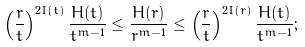<formula> <loc_0><loc_0><loc_500><loc_500>\left ( \frac { r } { t } \right ) ^ { 2 I ( t ) } \frac { H ( t ) } { t ^ { m - 1 } } \leq \frac { H ( r ) } { r ^ { m - 1 } } \leq \left ( \frac { r } { t } \right ) ^ { 2 I ( r ) } \frac { H ( t ) } { t ^ { m - 1 } } ;</formula> 